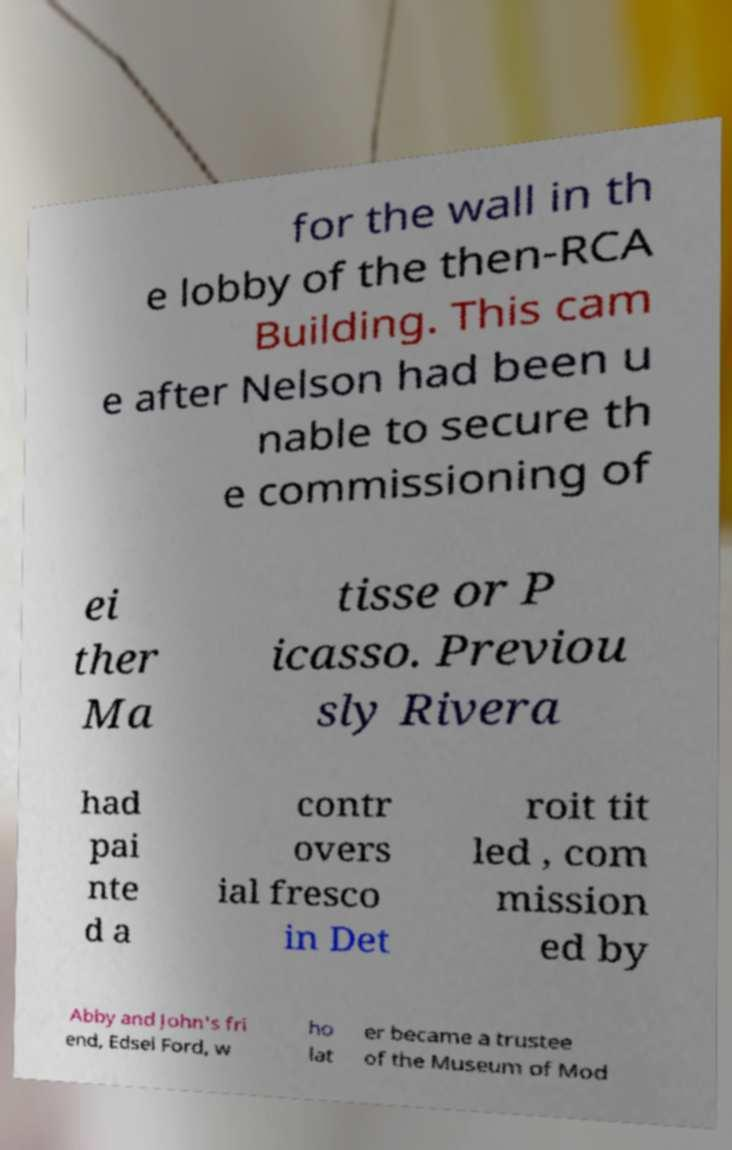For documentation purposes, I need the text within this image transcribed. Could you provide that? for the wall in th e lobby of the then-RCA Building. This cam e after Nelson had been u nable to secure th e commissioning of ei ther Ma tisse or P icasso. Previou sly Rivera had pai nte d a contr overs ial fresco in Det roit tit led , com mission ed by Abby and John's fri end, Edsel Ford, w ho lat er became a trustee of the Museum of Mod 